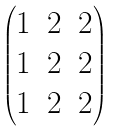<formula> <loc_0><loc_0><loc_500><loc_500>\begin{pmatrix} 1 & 2 & 2 \\ 1 & 2 & 2 \\ 1 & 2 & 2 \end{pmatrix}</formula> 